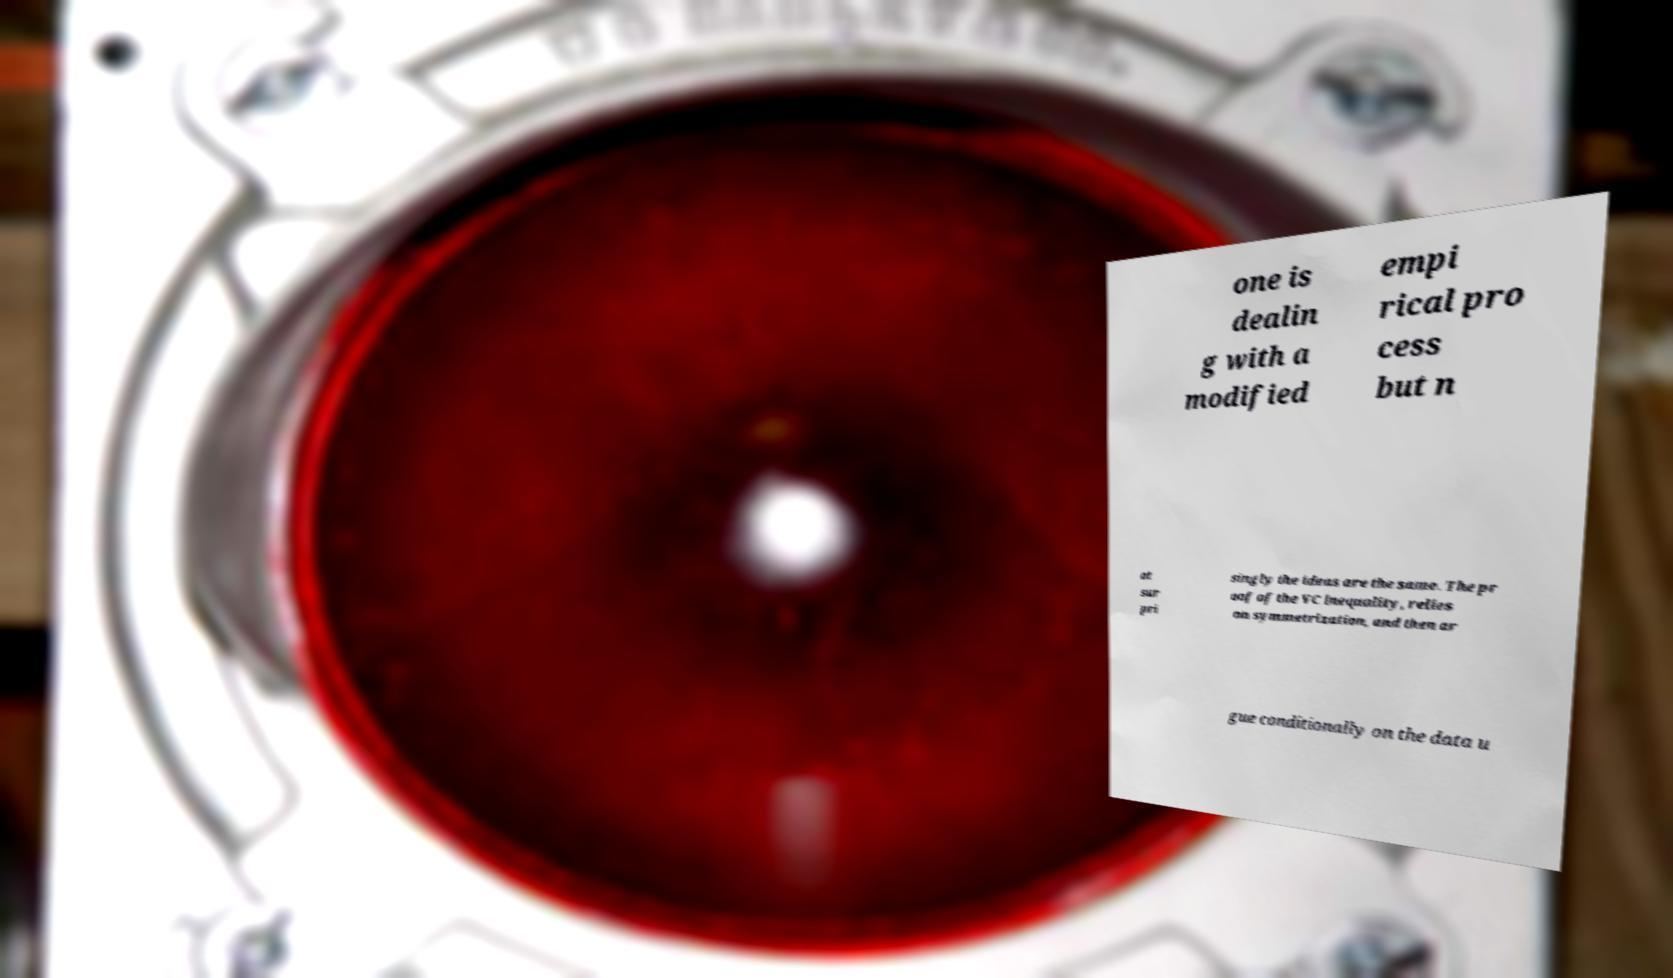For documentation purposes, I need the text within this image transcribed. Could you provide that? one is dealin g with a modified empi rical pro cess but n ot sur pri singly the ideas are the same. The pr oof of the VC inequality, relies on symmetrization, and then ar gue conditionally on the data u 